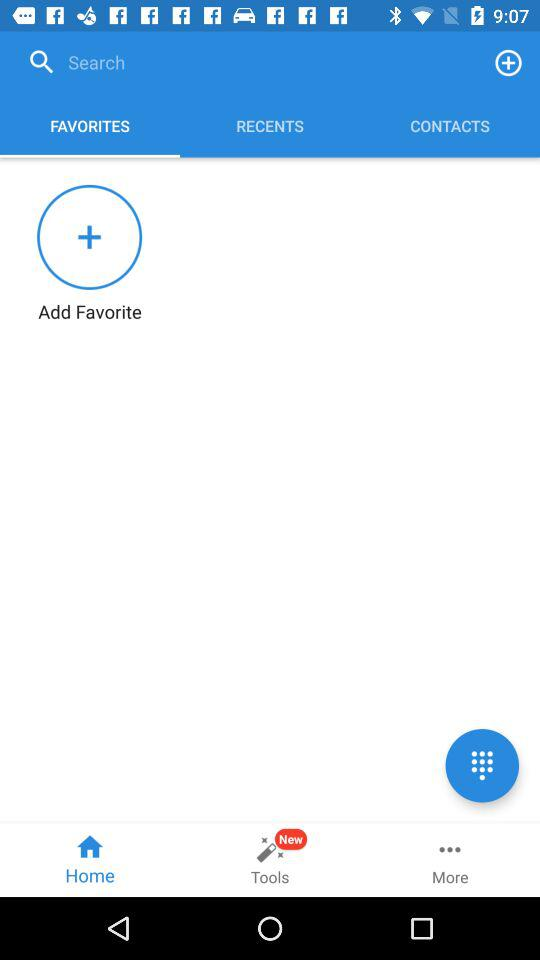Which tab is selected? The selected tab is "FAVORITES". 